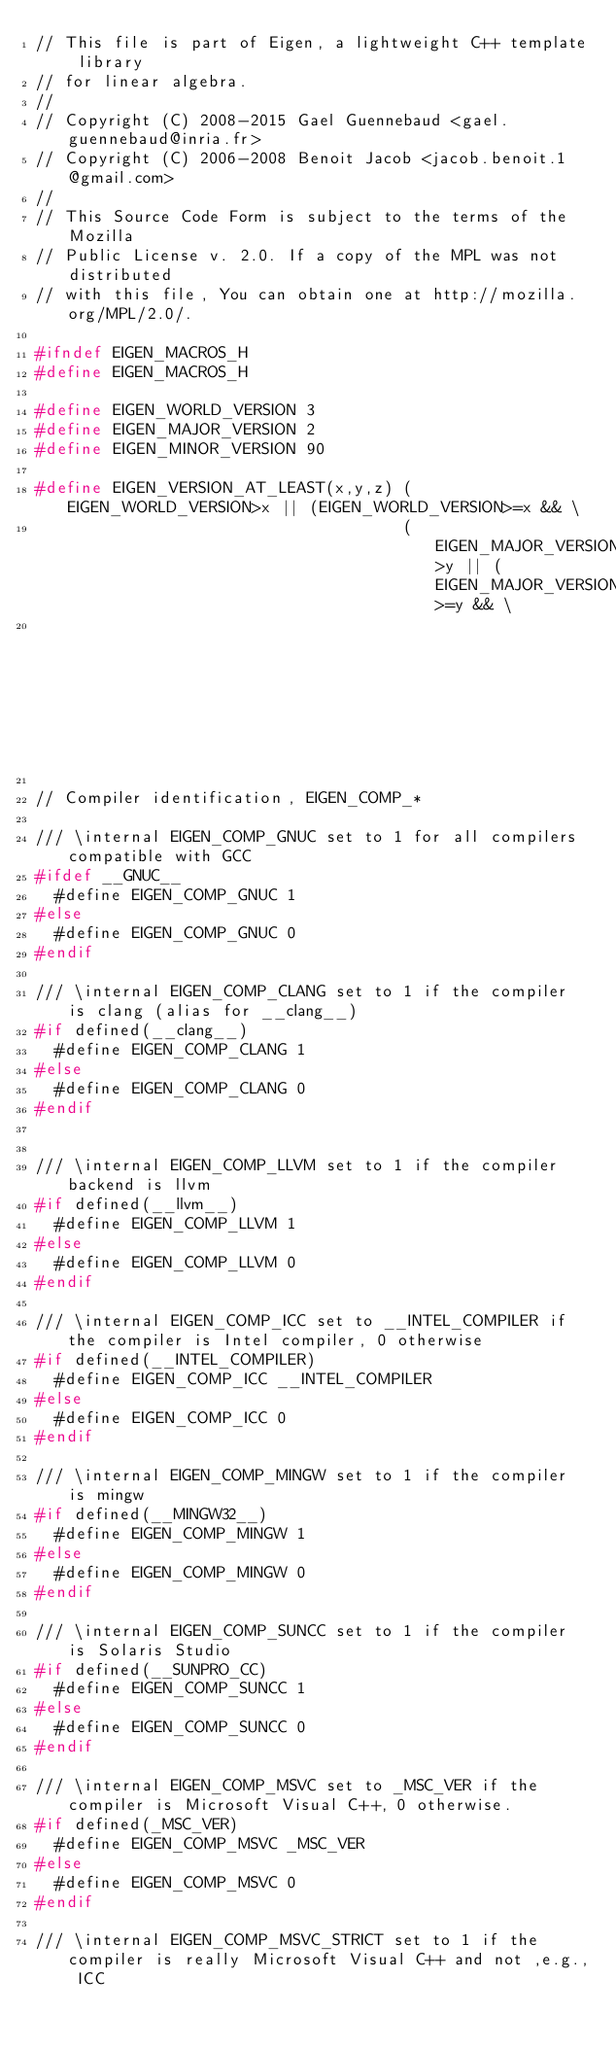<code> <loc_0><loc_0><loc_500><loc_500><_C_>// This file is part of Eigen, a lightweight C++ template library
// for linear algebra.
//
// Copyright (C) 2008-2015 Gael Guennebaud <gael.guennebaud@inria.fr>
// Copyright (C) 2006-2008 Benoit Jacob <jacob.benoit.1@gmail.com>
//
// This Source Code Form is subject to the terms of the Mozilla
// Public License v. 2.0. If a copy of the MPL was not distributed
// with this file, You can obtain one at http://mozilla.org/MPL/2.0/.

#ifndef EIGEN_MACROS_H
#define EIGEN_MACROS_H

#define EIGEN_WORLD_VERSION 3
#define EIGEN_MAJOR_VERSION 2
#define EIGEN_MINOR_VERSION 90

#define EIGEN_VERSION_AT_LEAST(x,y,z) (EIGEN_WORLD_VERSION>x || (EIGEN_WORLD_VERSION>=x && \
                                      (EIGEN_MAJOR_VERSION>y || (EIGEN_MAJOR_VERSION>=y && \
                                                                 EIGEN_MINOR_VERSION>=z))))

// Compiler identification, EIGEN_COMP_*

/// \internal EIGEN_COMP_GNUC set to 1 for all compilers compatible with GCC
#ifdef __GNUC__
  #define EIGEN_COMP_GNUC 1
#else
  #define EIGEN_COMP_GNUC 0
#endif

/// \internal EIGEN_COMP_CLANG set to 1 if the compiler is clang (alias for __clang__)
#if defined(__clang__)
  #define EIGEN_COMP_CLANG 1
#else
  #define EIGEN_COMP_CLANG 0
#endif


/// \internal EIGEN_COMP_LLVM set to 1 if the compiler backend is llvm
#if defined(__llvm__)
  #define EIGEN_COMP_LLVM 1
#else
  #define EIGEN_COMP_LLVM 0
#endif

/// \internal EIGEN_COMP_ICC set to __INTEL_COMPILER if the compiler is Intel compiler, 0 otherwise
#if defined(__INTEL_COMPILER)
  #define EIGEN_COMP_ICC __INTEL_COMPILER
#else
  #define EIGEN_COMP_ICC 0
#endif

/// \internal EIGEN_COMP_MINGW set to 1 if the compiler is mingw
#if defined(__MINGW32__)
  #define EIGEN_COMP_MINGW 1
#else
  #define EIGEN_COMP_MINGW 0
#endif

/// \internal EIGEN_COMP_SUNCC set to 1 if the compiler is Solaris Studio
#if defined(__SUNPRO_CC)
  #define EIGEN_COMP_SUNCC 1
#else
  #define EIGEN_COMP_SUNCC 0
#endif

/// \internal EIGEN_COMP_MSVC set to _MSC_VER if the compiler is Microsoft Visual C++, 0 otherwise.
#if defined(_MSC_VER)
  #define EIGEN_COMP_MSVC _MSC_VER
#else
  #define EIGEN_COMP_MSVC 0
#endif

/// \internal EIGEN_COMP_MSVC_STRICT set to 1 if the compiler is really Microsoft Visual C++ and not ,e.g., ICC</code> 